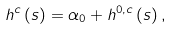<formula> <loc_0><loc_0><loc_500><loc_500>h ^ { c } \left ( s \right ) = \alpha _ { 0 } + h ^ { 0 , c } \left ( s \right ) ,</formula> 